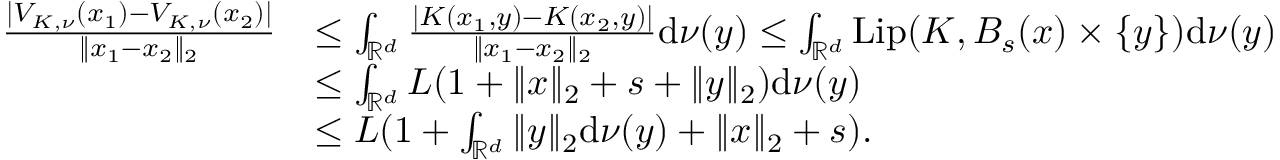<formula> <loc_0><loc_0><loc_500><loc_500>\begin{array} { r l } { \frac { | V _ { K , \nu } ( x _ { 1 } ) - V _ { K , \nu } ( x _ { 2 } ) | } { \| x _ { 1 } - x _ { 2 } \| _ { 2 } } } & { \leq \int _ { \mathbb { R } ^ { d } } \frac { | K ( x _ { 1 } , y ) - K ( x _ { 2 } , y ) | } { \| x _ { 1 } - x _ { 2 } \| _ { 2 } } d \nu ( y ) \leq \int _ { \mathbb { R } ^ { d } } L i p ( K , B _ { s } ( x ) \times \{ y \} ) d \nu ( y ) } \\ & { \leq \int _ { \mathbb { R } ^ { d } } L ( 1 + \| x \| _ { 2 } + s + \| y \| _ { 2 } ) d \nu ( y ) } \\ & { \leq L ( 1 + \int _ { \mathbb { R } ^ { d } } \| y \| _ { 2 } d \nu ( y ) + \| x \| _ { 2 } + s ) . } \end{array}</formula> 